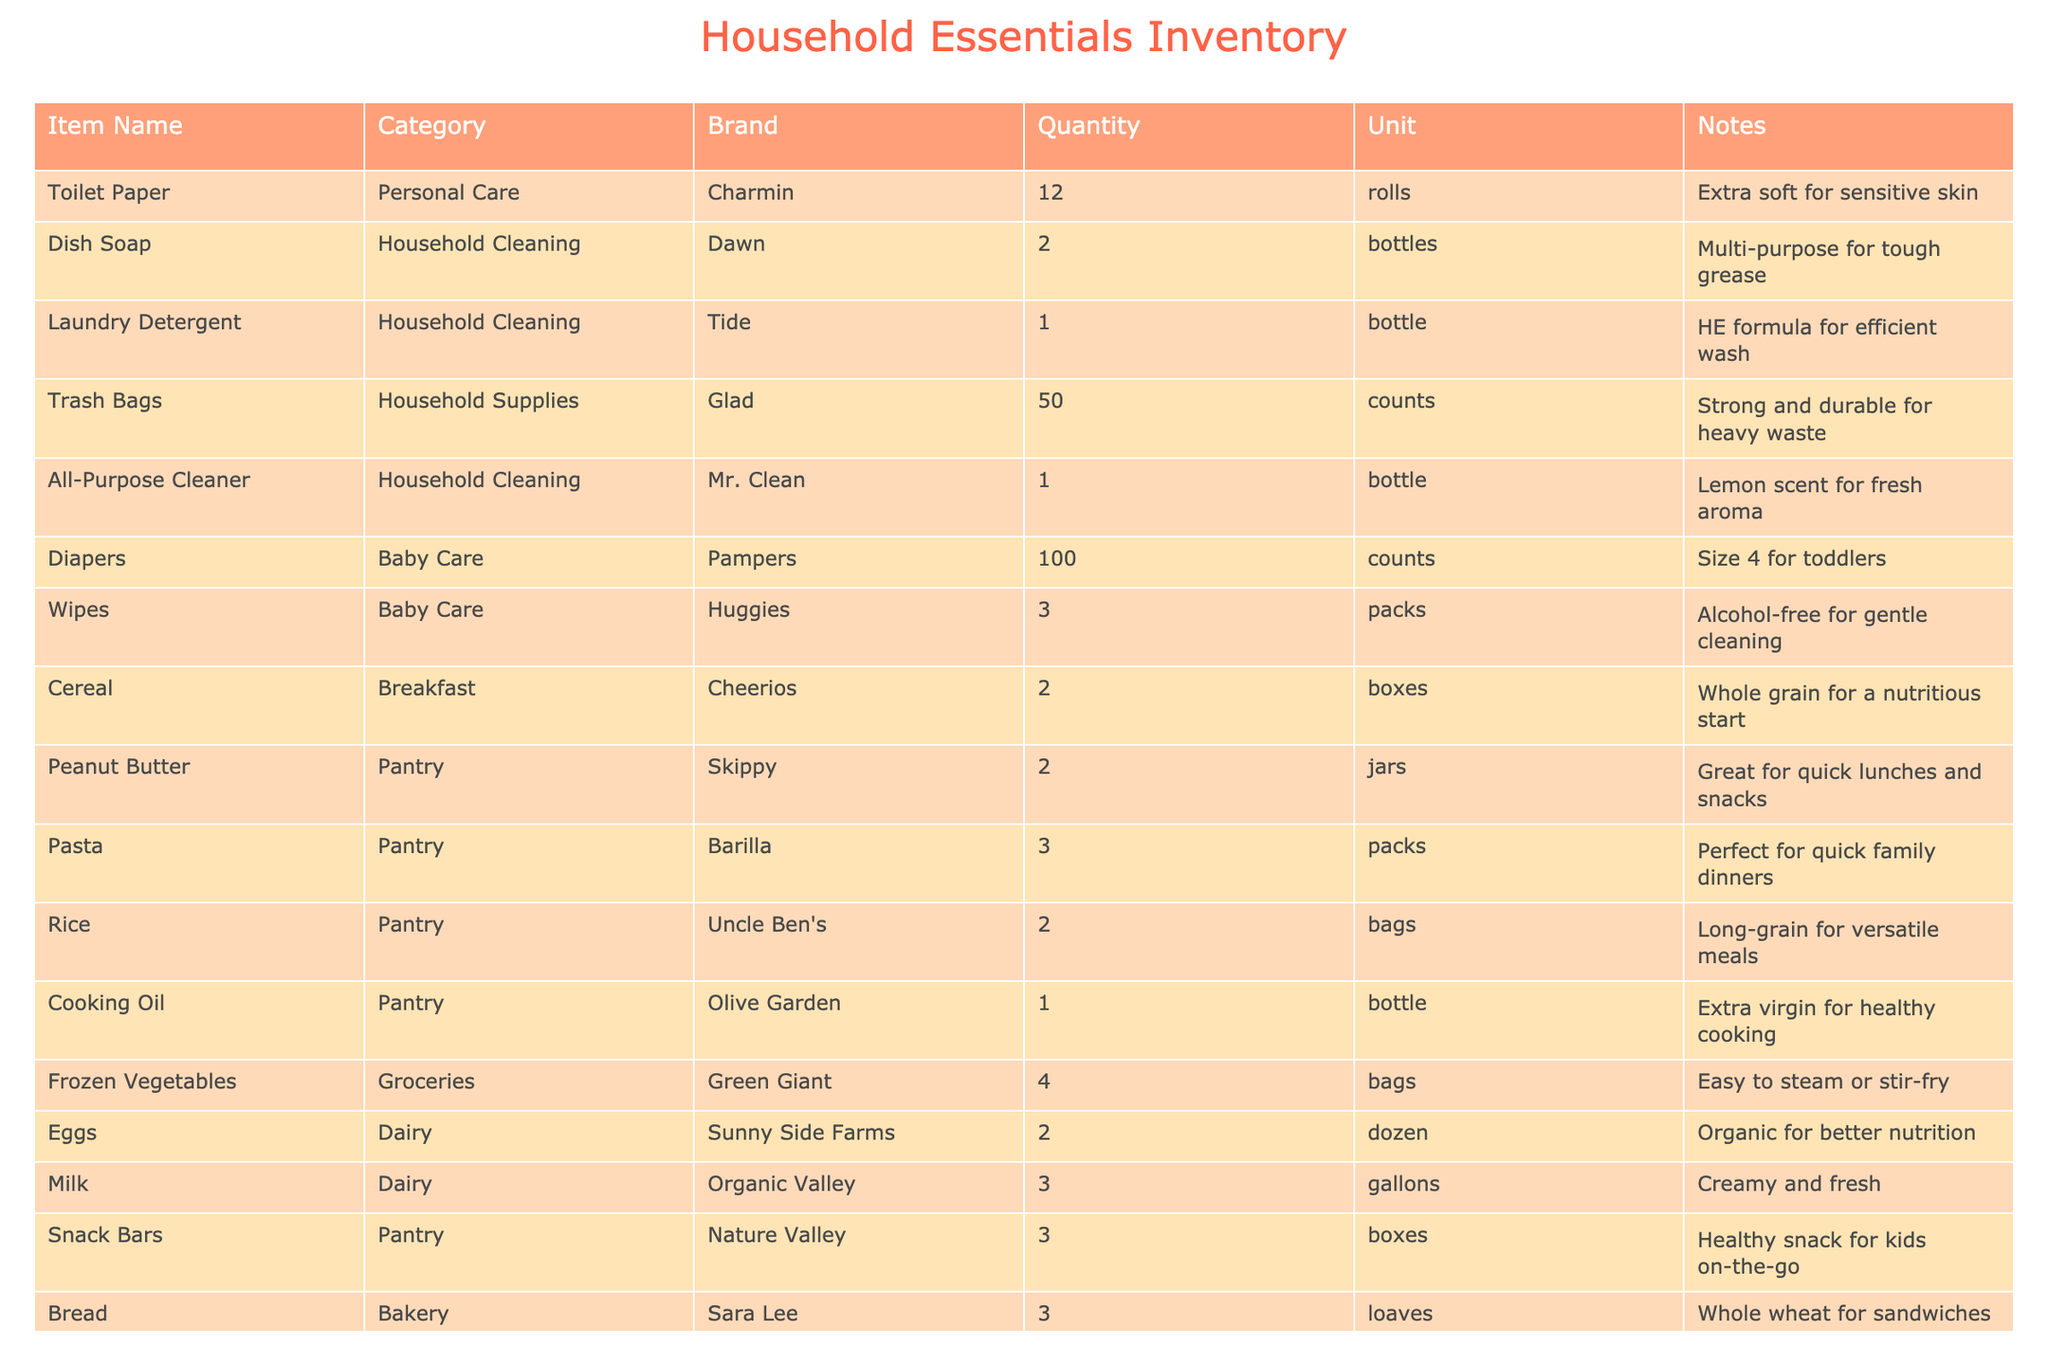What is the total quantity of diapers available? Looking at the row for Diapers, there are 100 counts listed under Quantity. Therefore, the total quantity of diapers available is simply 100.
Answer: 100 How many different brands of laundry detergent are listed? The table shows only one entry for laundry detergent, which is Tide. Therefore, there is only 1 brand of laundry detergent listed.
Answer: 1 Is there any household cleaning item that comes in more than one bottle? From the table, the only household cleaning item listed as having more than one bottle is Dish Soap with 2 bottles. Other cleaning items like Laundry Detergent, All-Purpose Cleaner only have 1 bottle. So yes, there is at least one item that meets this criteria.
Answer: Yes What is the total number of packs of wipes and boxes of snack bars combined? For Wipes, there are 3 packs; for Snack Bars, there are 3 boxes. Adding these together gives us a total of 3 + 3 = 6 packs and boxes combined.
Answer: 6 Which item has the highest quantity and how many are there? By reviewing the quantities of all items, Diapers has the highest quantity at 100 counts. Other items do not exceed this amount.
Answer: 100 How many different categories of household essentials are represented in this inventory? The categories listed in the table include Personal Care, Household Cleaning, Household Supplies, Baby Care, Breakfast, Pantry, Groceries, and Dairy. In total, there are 8 different categories.
Answer: 8 What is the average number of rolls of toilet paper and loaves of bread? The quantity of toilet paper is 12 rolls and bread is 3 loaves. The total quantity is 12 + 3 = 15. Dividing by the number of items (2) gives an average of 15/2 = 7.5.
Answer: 7.5 Are there any items that are organic? Yes, the table specifies Organic for both Eggs and Milk. Thus, there are items that are labeled as organic.
Answer: Yes What is the overall total quantity of household supplies listed under the 'Household Supplies' category? The only item under Household Supplies is Trash Bags, which has a quantity of 50. Therefore, the overall total quantity for this category is simply 50.
Answer: 50 